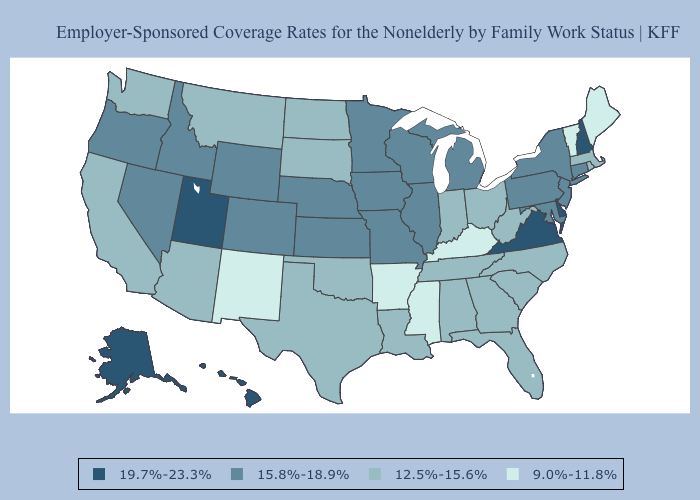Does Illinois have the same value as Wisconsin?
Short answer required. Yes. Name the states that have a value in the range 12.5%-15.6%?
Be succinct. Alabama, Arizona, California, Florida, Georgia, Indiana, Louisiana, Massachusetts, Montana, North Carolina, North Dakota, Ohio, Oklahoma, Rhode Island, South Carolina, South Dakota, Tennessee, Texas, Washington, West Virginia. Name the states that have a value in the range 15.8%-18.9%?
Quick response, please. Colorado, Connecticut, Idaho, Illinois, Iowa, Kansas, Maryland, Michigan, Minnesota, Missouri, Nebraska, Nevada, New Jersey, New York, Oregon, Pennsylvania, Wisconsin, Wyoming. Which states hav the highest value in the MidWest?
Concise answer only. Illinois, Iowa, Kansas, Michigan, Minnesota, Missouri, Nebraska, Wisconsin. What is the lowest value in the USA?
Quick response, please. 9.0%-11.8%. What is the value of Washington?
Be succinct. 12.5%-15.6%. Which states have the lowest value in the Northeast?
Answer briefly. Maine, Vermont. What is the value of North Carolina?
Be succinct. 12.5%-15.6%. Name the states that have a value in the range 9.0%-11.8%?
Answer briefly. Arkansas, Kentucky, Maine, Mississippi, New Mexico, Vermont. Among the states that border Nevada , does Utah have the highest value?
Short answer required. Yes. What is the lowest value in states that border Utah?
Keep it brief. 9.0%-11.8%. Does the map have missing data?
Quick response, please. No. What is the lowest value in the USA?
Be succinct. 9.0%-11.8%. What is the value of Pennsylvania?
Keep it brief. 15.8%-18.9%. Which states have the lowest value in the Northeast?
Give a very brief answer. Maine, Vermont. 